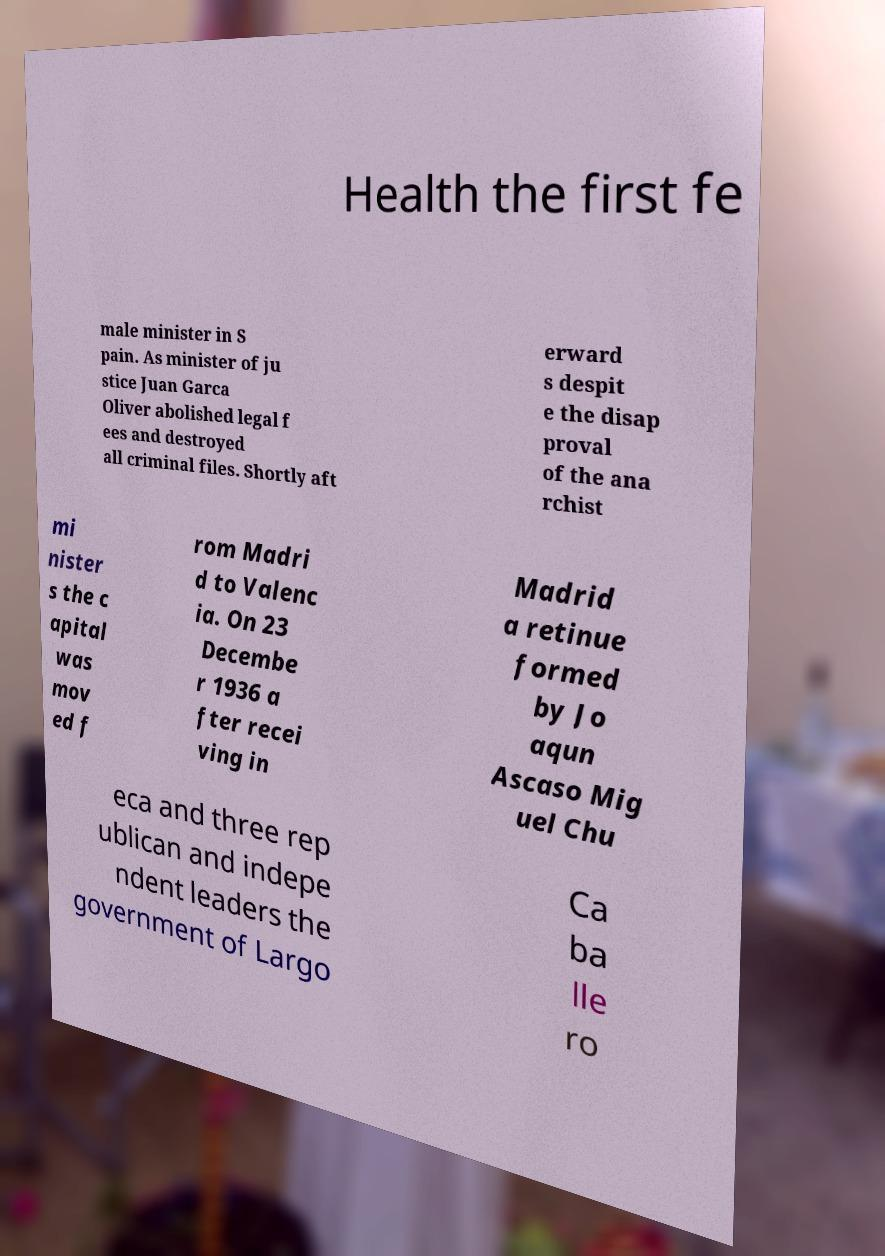What messages or text are displayed in this image? I need them in a readable, typed format. Health the first fe male minister in S pain. As minister of ju stice Juan Garca Oliver abolished legal f ees and destroyed all criminal files. Shortly aft erward s despit e the disap proval of the ana rchist mi nister s the c apital was mov ed f rom Madri d to Valenc ia. On 23 Decembe r 1936 a fter recei ving in Madrid a retinue formed by Jo aqun Ascaso Mig uel Chu eca and three rep ublican and indepe ndent leaders the government of Largo Ca ba lle ro 